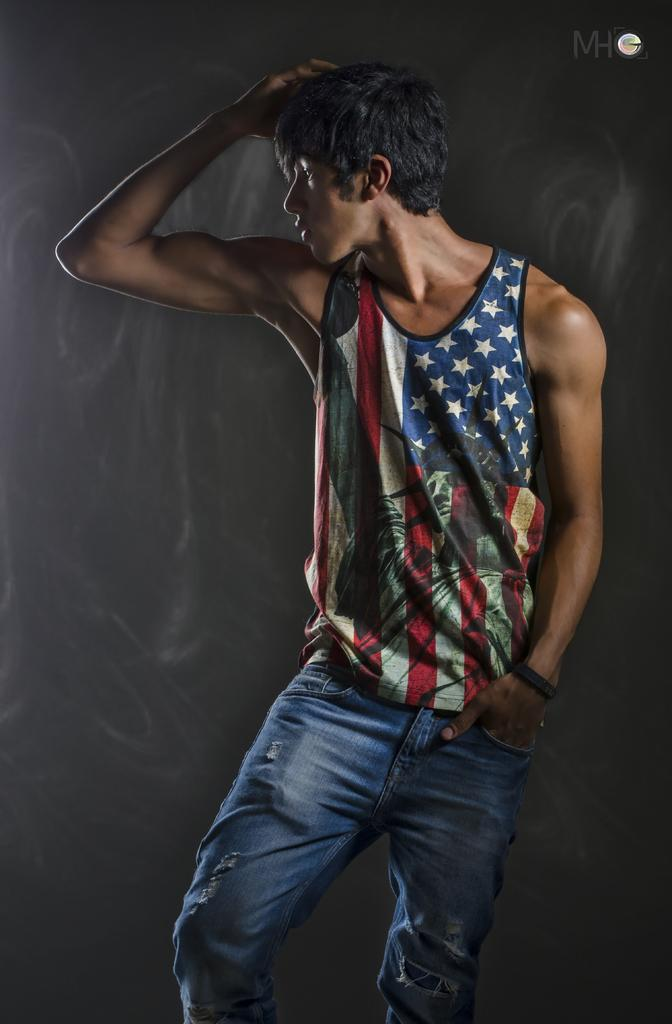Who is the main subject in the picture? The main subject in the picture is a boy. What is the boy wearing on his upper body? The boy is wearing an American pattern half-sleeve t-shirt. What type of pants is the boy wearing? The boy is wearing jeans. What is the boy doing in the picture? The boy is standing and giving a pose. What direction is the boy facing in the picture? The boy is facing the camera. What verse is the boy reciting in the picture? There is no indication in the image that the boy is reciting a verse, so it cannot be determined from the picture. 